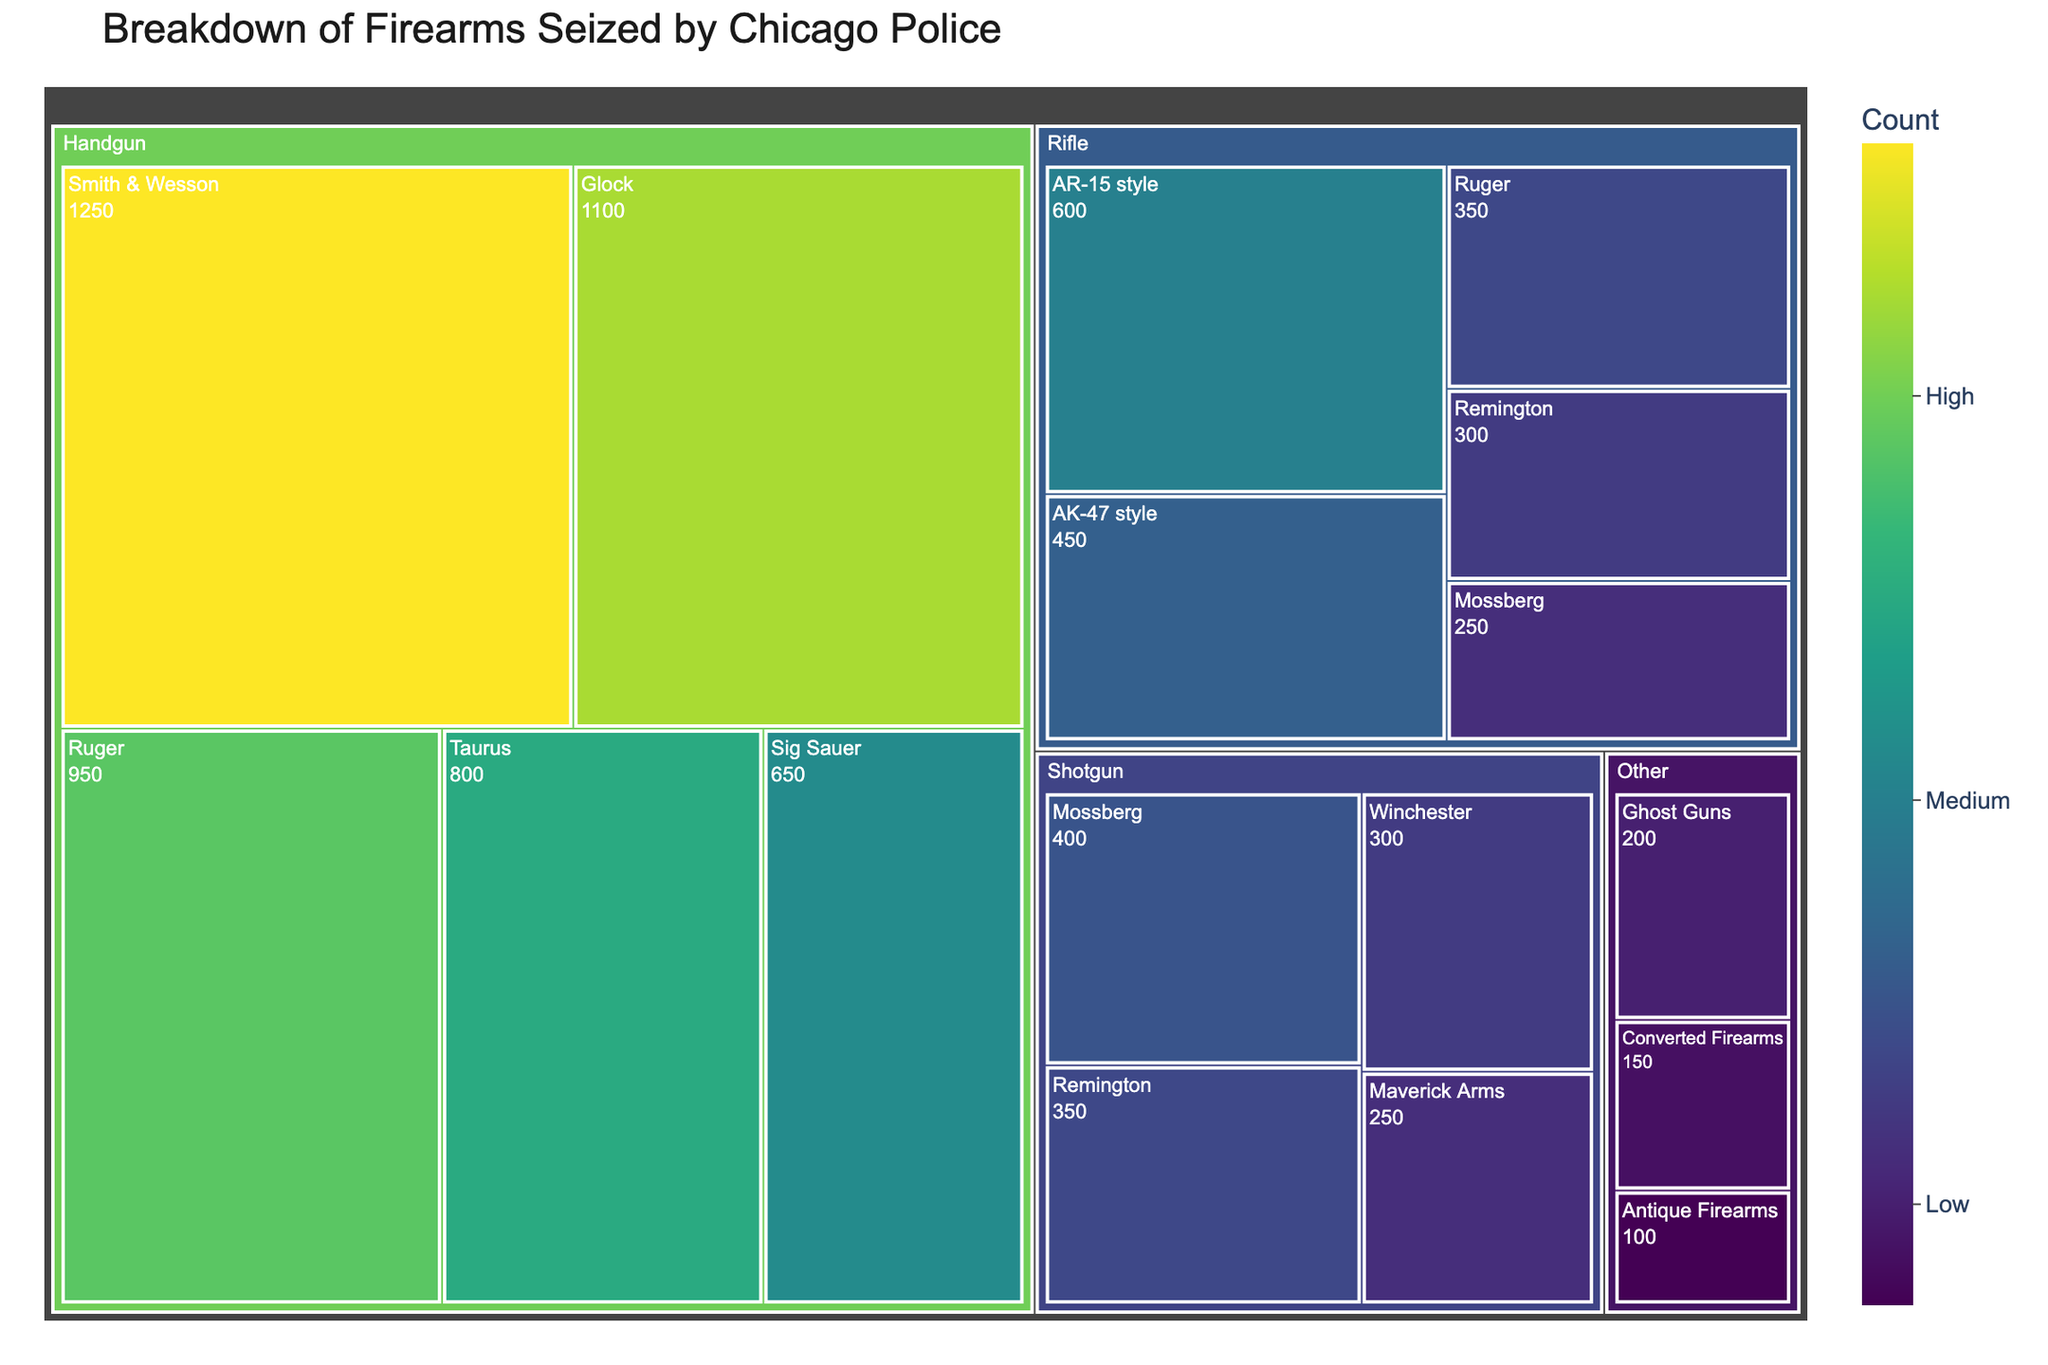What is the title of the figure? The title of the figure is usually displayed prominently at the top. It provides a brief summary of what the figure represents.
Answer: Breakdown of Firearms Seized by Chicago Police Which type of firearm has the highest count? To find the type with the highest count, look for the largest section in the treemap. The area size usually corresponds to the count.
Answer: Handgun How many firearms were seized from Glock manufacturers? Look for the segment labeled "Glock" under the "Handgun" category. The count is displayed within the segment.
Answer: 1100 What is the total number of "Other" type firearms seized? To find the total for the "Other" type, sum the counts of all segments under the "Other" category: Ghost Guns (200), Converted Firearms (150), and Antique Firearms (100).
Answer: 450 How does the number of AR-15 style rifles compare to AK-47 style rifles seized? Compare the count of AR-15 style rifles to AK-47 style rifles by finding their segments in the "Rifle" category.
Answer: AR-15 style rifles (600) are more than AK-47 style rifles (450) Which shotgun manufacturer has the highest count of seized firearms? Look for the largest segment within the "Shotgun" category. The count and manufacturer name are displayed.
Answer: Mossberg What is the ratio of handguns seized from Smith & Wesson compared to Ruger? The count for Smith & Wesson is 1250 and for Ruger is 950. The ratio is found by dividing the counts.
Answer: 1250:950 or 1.32:1 How many more handguns were seized compared to rifles? Find the total count of handguns (1250 + 1100 + 950 + 800 + 650 = 4750) and rifles (600 + 450 + 350 + 300 + 250 = 1950), then subtract the rifle count from the handgun count.
Answer: 2800 What is the average number of firearms seized per manufacturer in the "Shotgun" category? Sum the counts for all shotgun manufacturers (400 + 350 + 300 + 250 = 1300) and divide by the number of manufacturers (4).
Answer: 325 